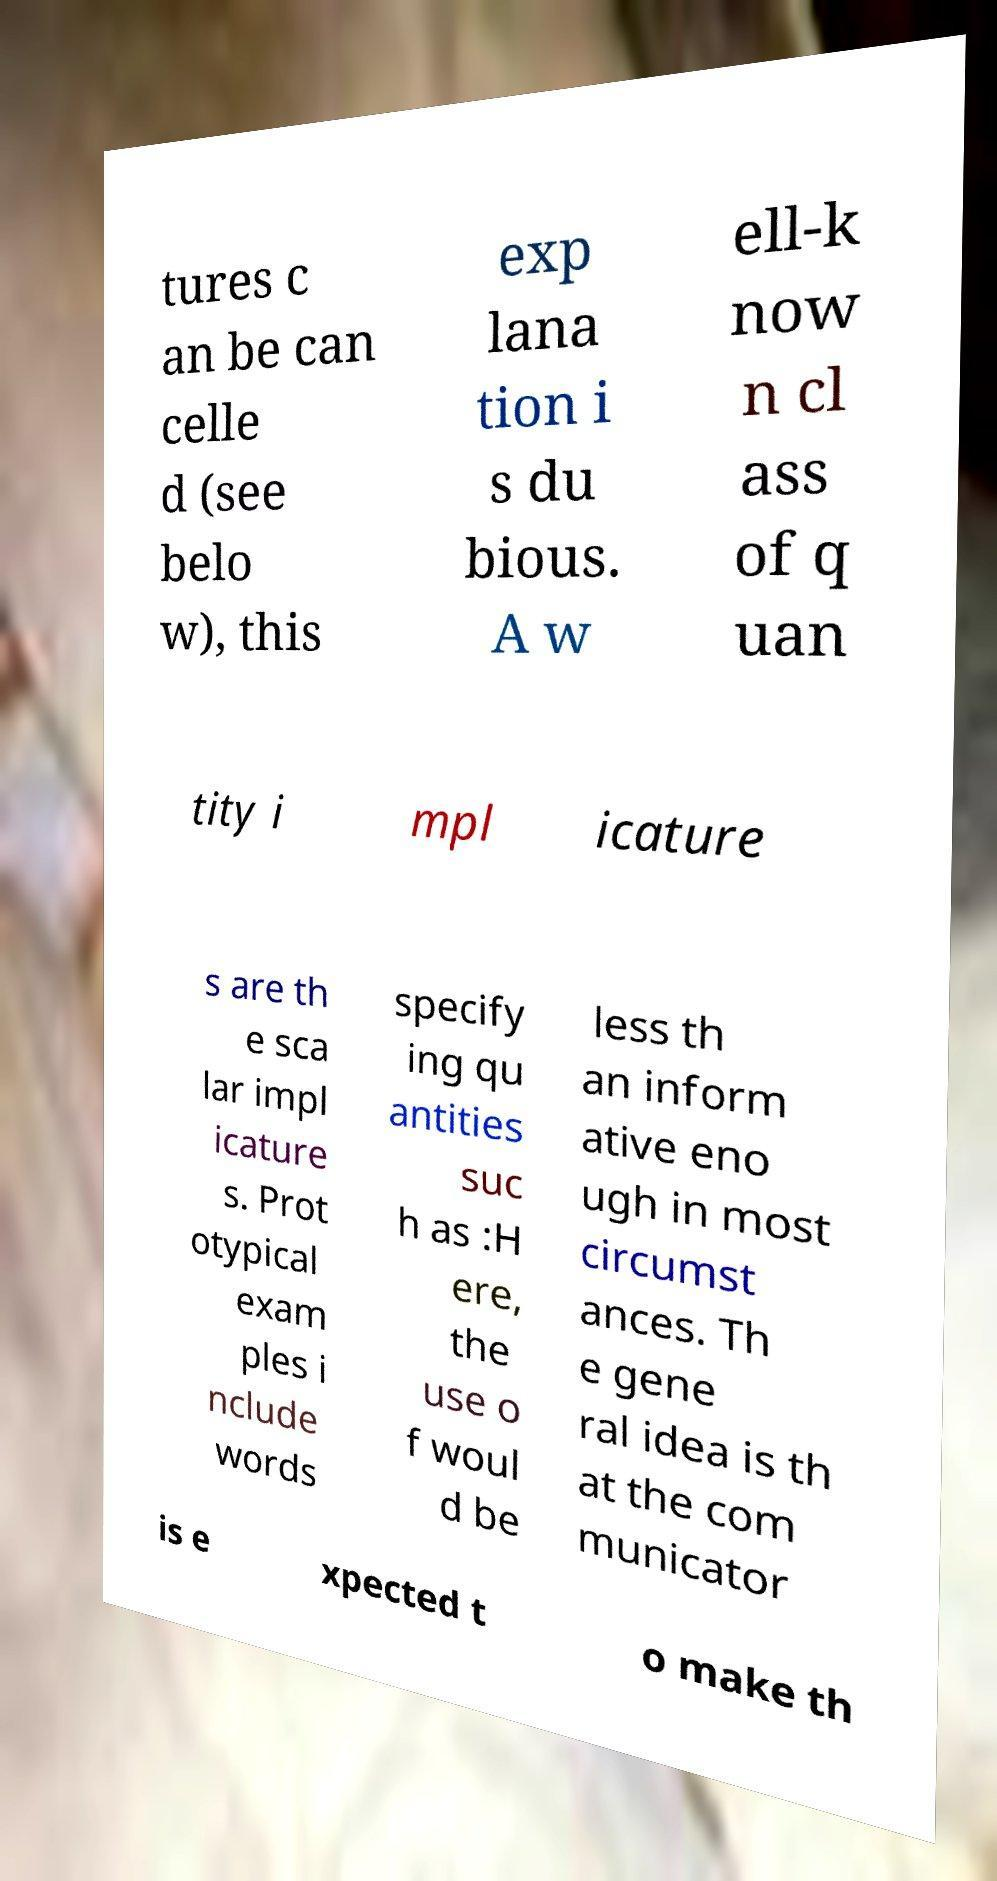Could you extract and type out the text from this image? tures c an be can celle d (see belo w), this exp lana tion i s du bious. A w ell-k now n cl ass of q uan tity i mpl icature s are th e sca lar impl icature s. Prot otypical exam ples i nclude words specify ing qu antities suc h as :H ere, the use o f woul d be less th an inform ative eno ugh in most circumst ances. Th e gene ral idea is th at the com municator is e xpected t o make th 